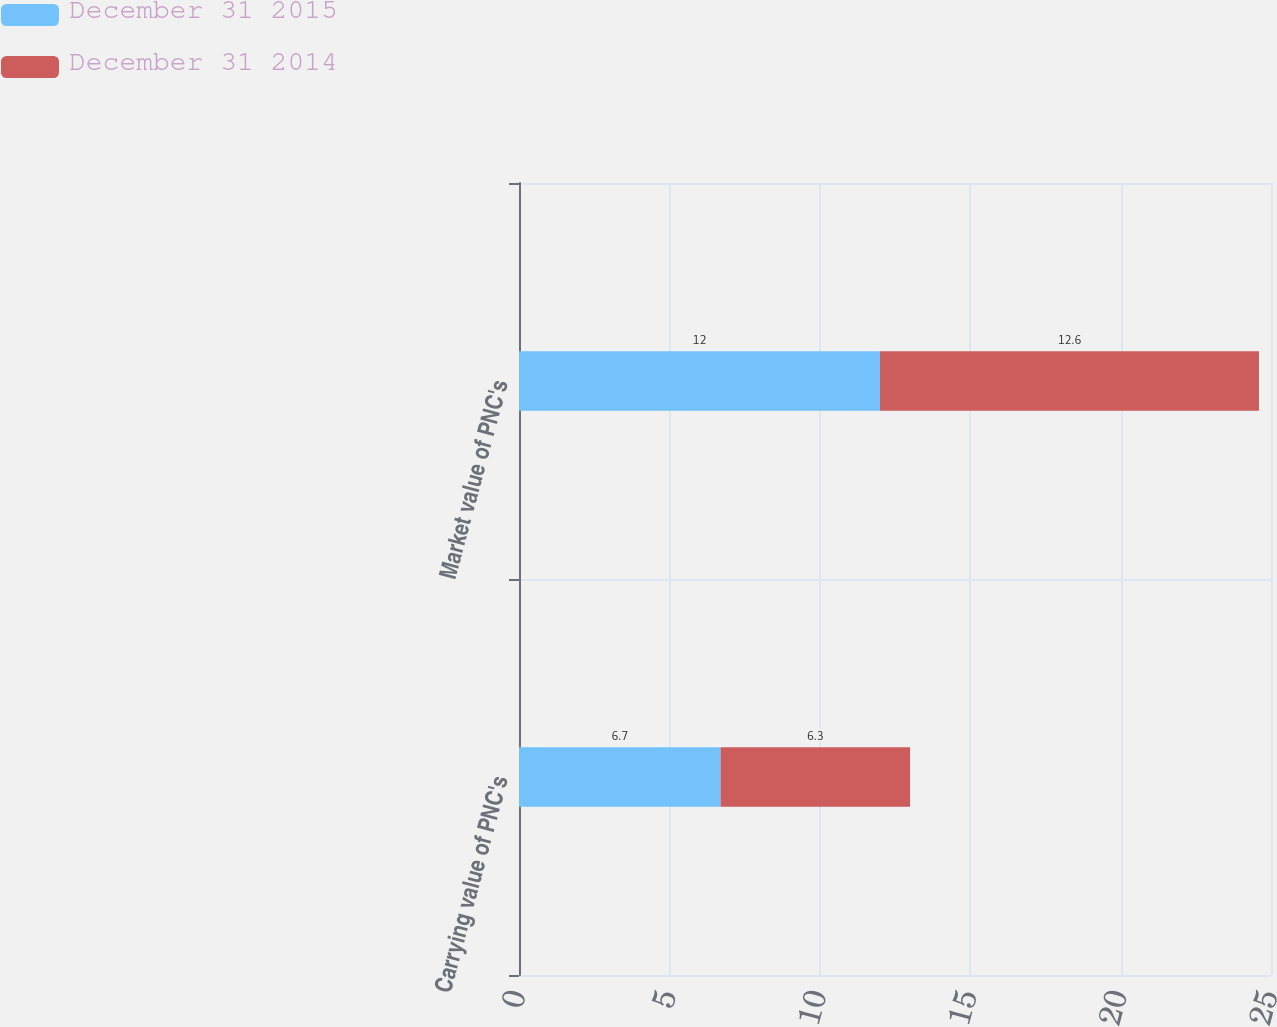Convert chart. <chart><loc_0><loc_0><loc_500><loc_500><stacked_bar_chart><ecel><fcel>Carrying value of PNC's<fcel>Market value of PNC's<nl><fcel>December 31 2015<fcel>6.7<fcel>12<nl><fcel>December 31 2014<fcel>6.3<fcel>12.6<nl></chart> 